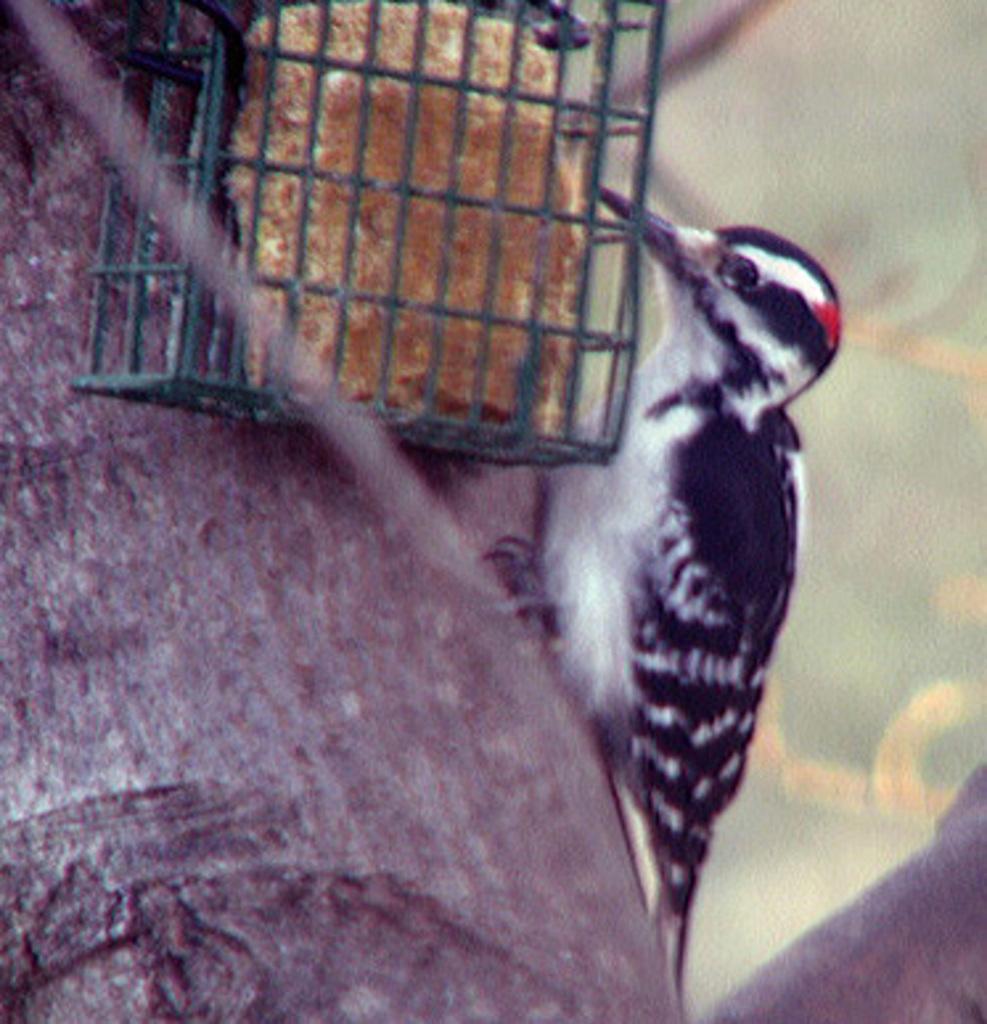Could you give a brief overview of what you see in this image? There is a bird in black and white color combination standing on the branch of a tree near a cage in which, there is an object and is attached to the tree. And the background is blurred. 